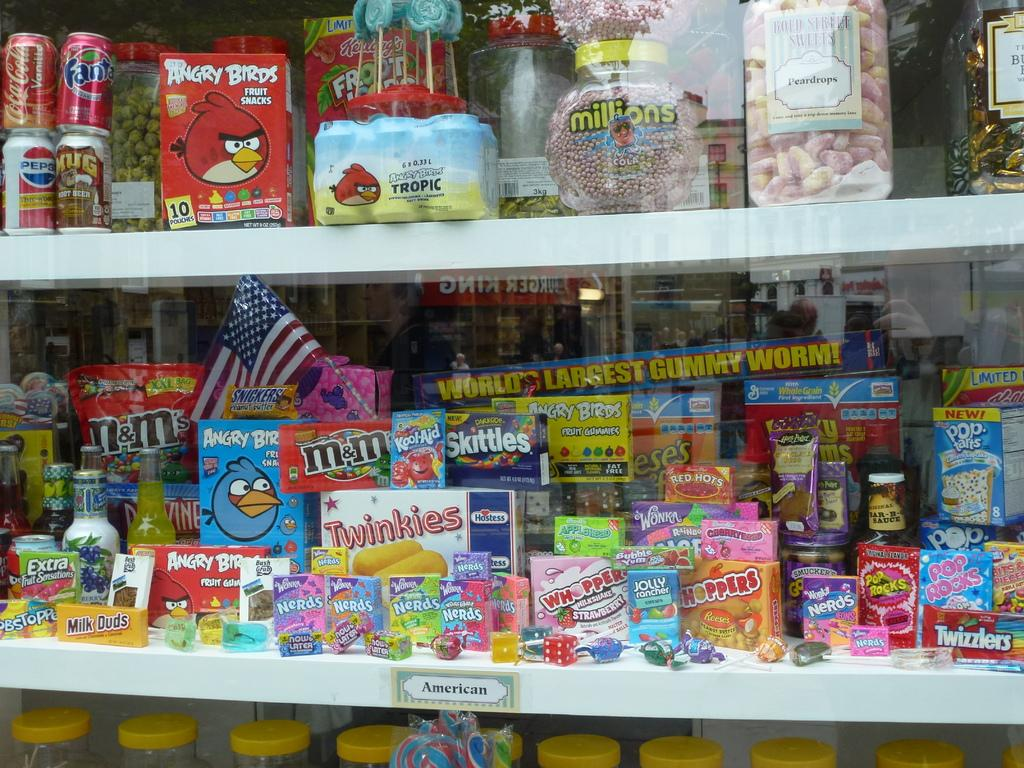<image>
Create a compact narrative representing the image presented. an Angry Birds toy that has many items near it 